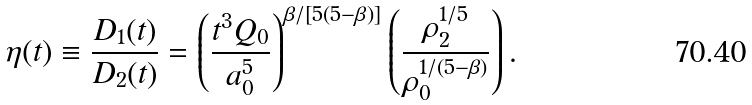<formula> <loc_0><loc_0><loc_500><loc_500>\eta ( t ) \equiv \frac { D _ { 1 } ( t ) } { D _ { 2 } ( t ) } = \left ( \frac { t ^ { 3 } Q _ { 0 } } { a _ { 0 } ^ { 5 } } \right ) ^ { \beta / [ 5 ( 5 - \beta ) ] } \left ( \frac { \rho _ { 2 } ^ { 1 / 5 } } { \rho _ { 0 } ^ { 1 / ( 5 - \beta ) } } \right ) .</formula> 